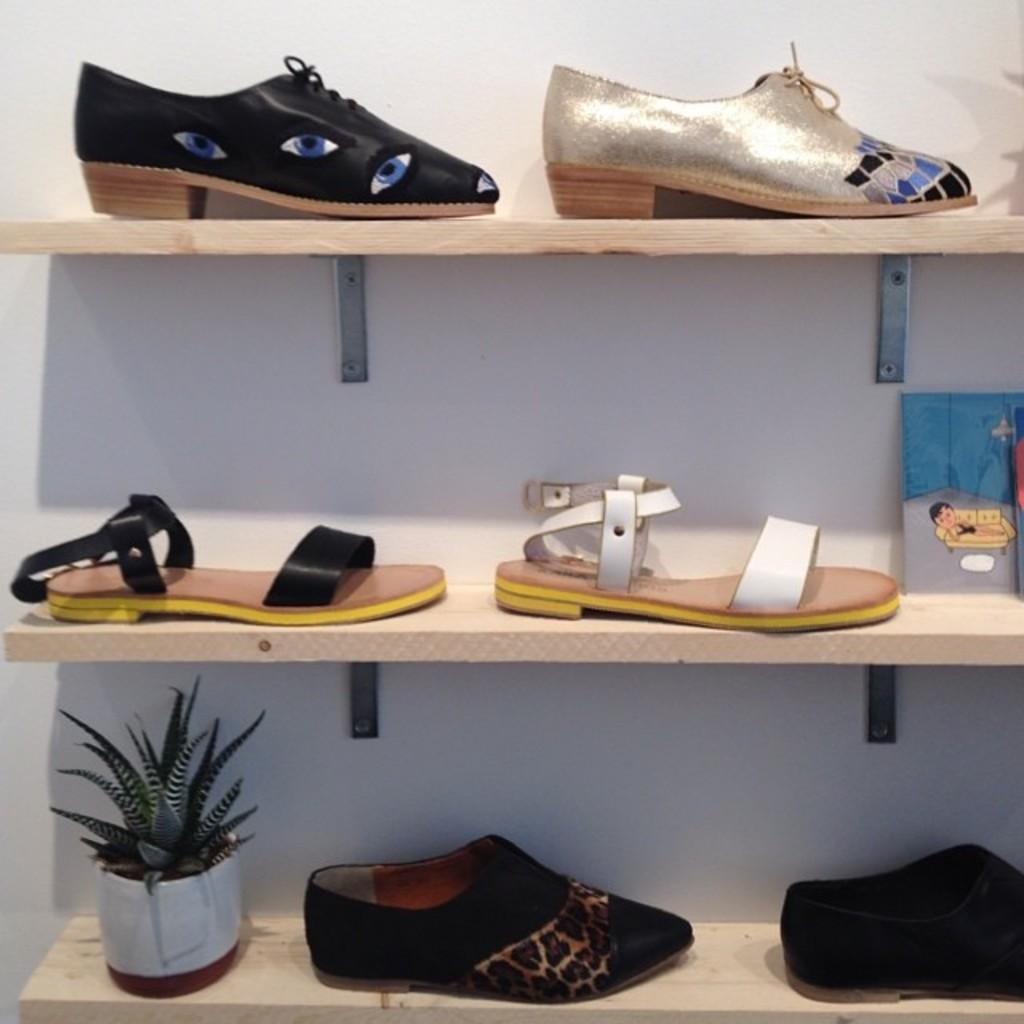What type of structure is visible in the image? There is a wall with shelves in the image. What items can be seen on the shelves? There are footwear and a plant in a pot on the shelves. Where is the key located in the image? There is no key present in the image. What type of war is depicted in the image? There is no war depicted in the image; it features a wall with shelves containing footwear and a plant in a pot. 